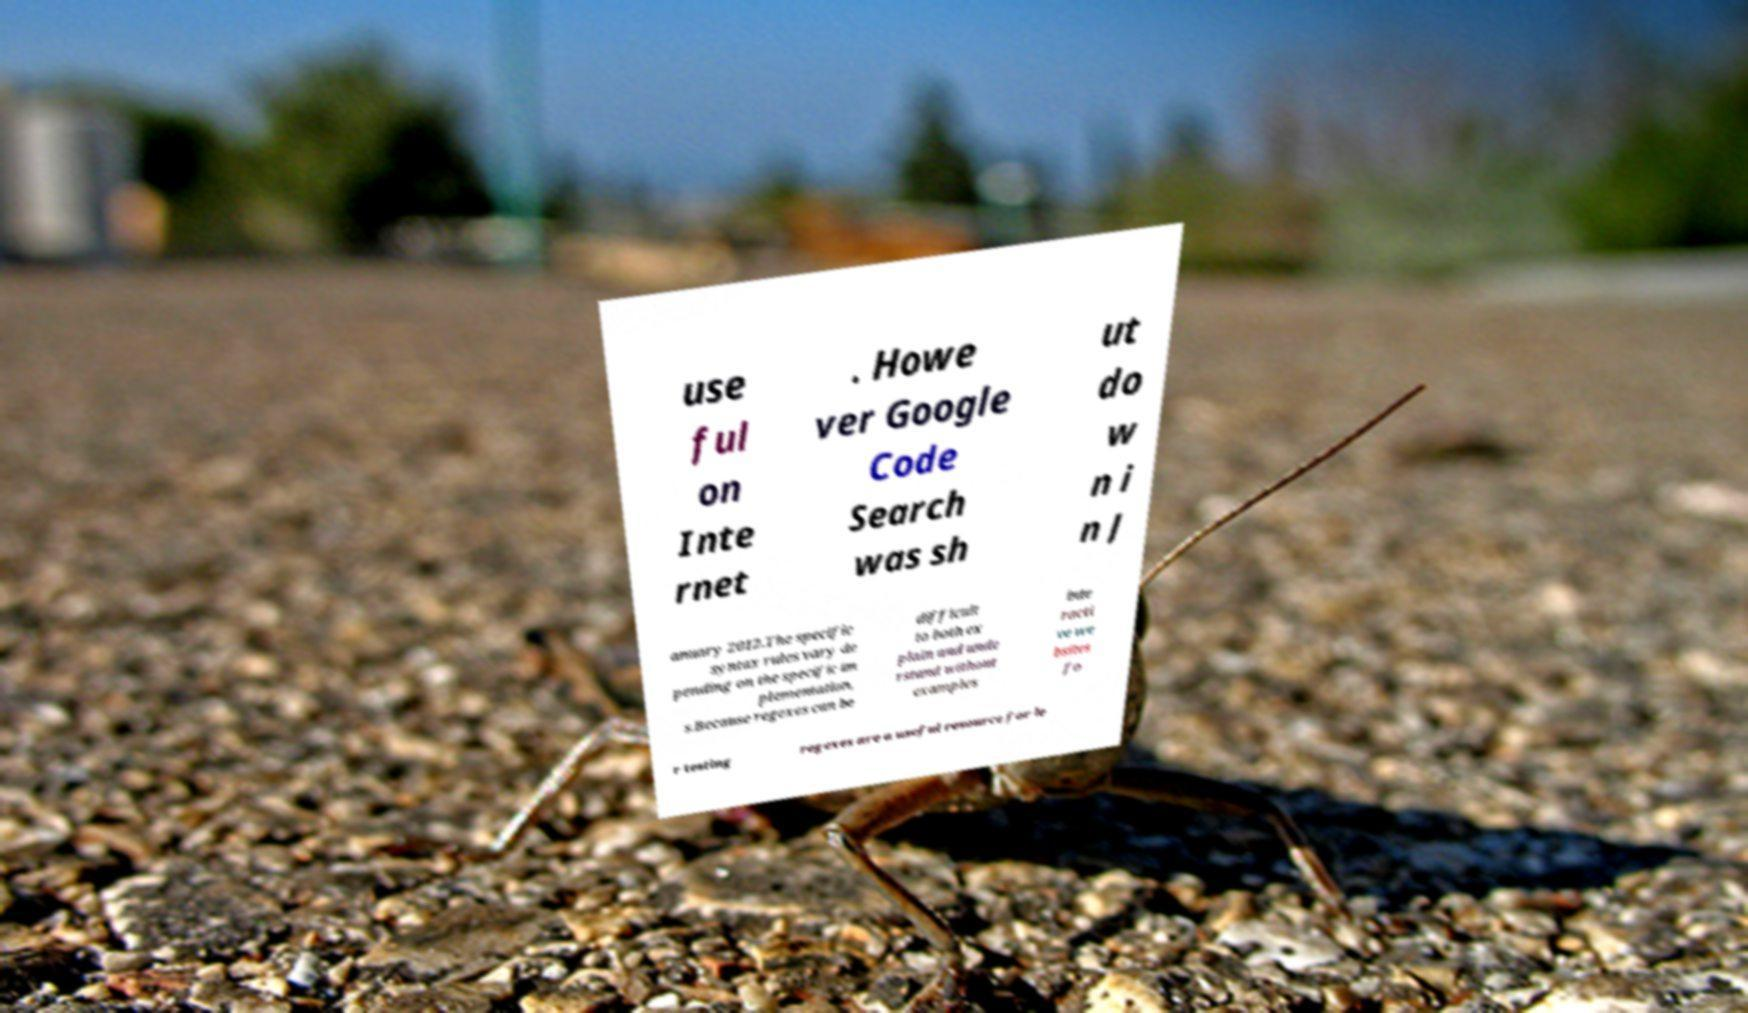Could you assist in decoding the text presented in this image and type it out clearly? use ful on Inte rnet . Howe ver Google Code Search was sh ut do w n i n J anuary 2012.The specific syntax rules vary de pending on the specific im plementation, s.Because regexes can be difficult to both ex plain and unde rstand without examples inte racti ve we bsites fo r testing regexes are a useful resource for le 